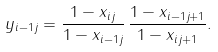Convert formula to latex. <formula><loc_0><loc_0><loc_500><loc_500>y _ { i - 1 j } = \frac { 1 - x _ { i j } } { 1 - x _ { i - 1 j } } \, \frac { 1 - x _ { i - 1 j + 1 } } { 1 - x _ { i j + 1 } } .</formula> 